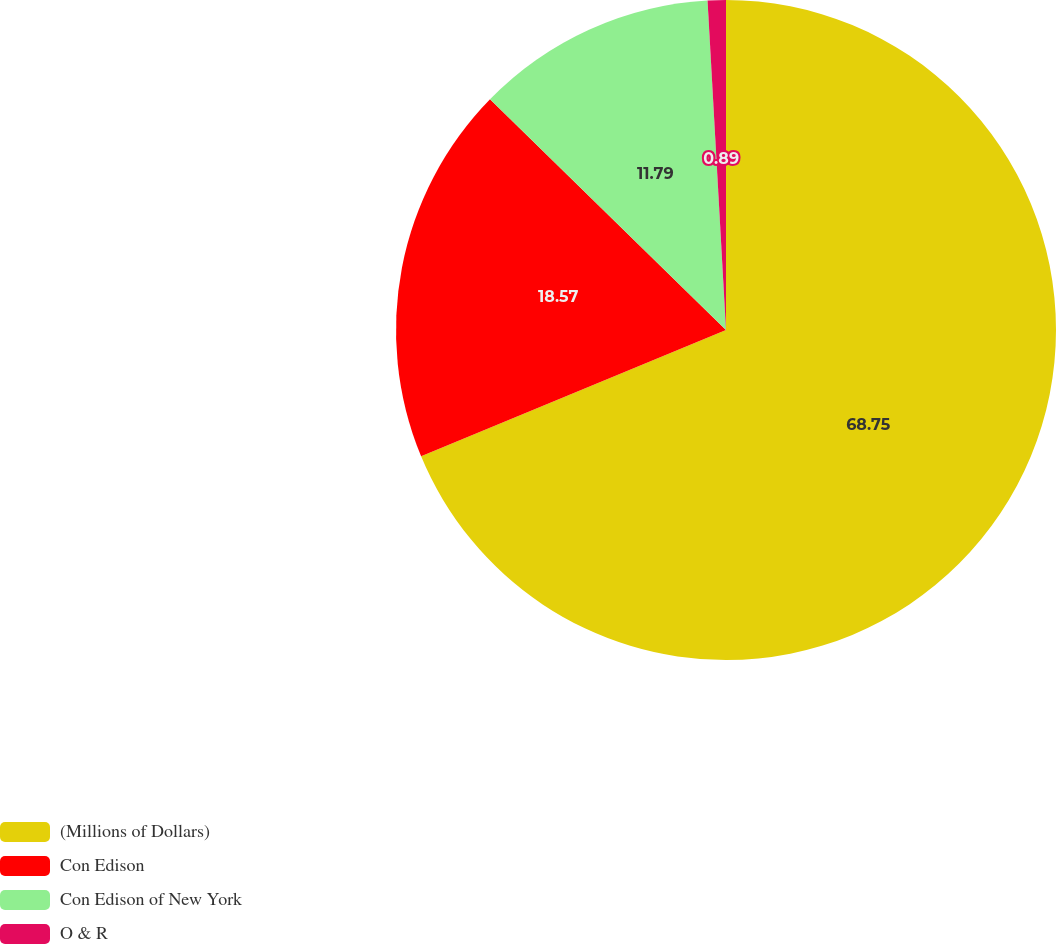Convert chart. <chart><loc_0><loc_0><loc_500><loc_500><pie_chart><fcel>(Millions of Dollars)<fcel>Con Edison<fcel>Con Edison of New York<fcel>O & R<nl><fcel>68.75%<fcel>18.57%<fcel>11.79%<fcel>0.89%<nl></chart> 